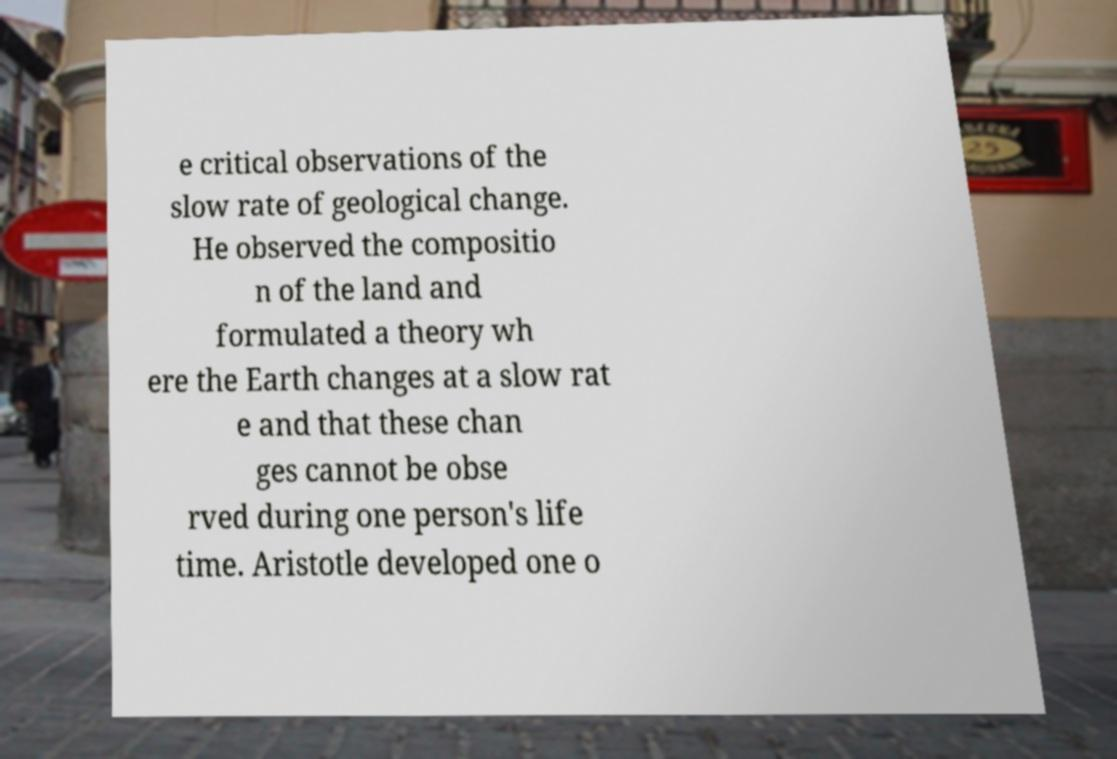For documentation purposes, I need the text within this image transcribed. Could you provide that? e critical observations of the slow rate of geological change. He observed the compositio n of the land and formulated a theory wh ere the Earth changes at a slow rat e and that these chan ges cannot be obse rved during one person's life time. Aristotle developed one o 